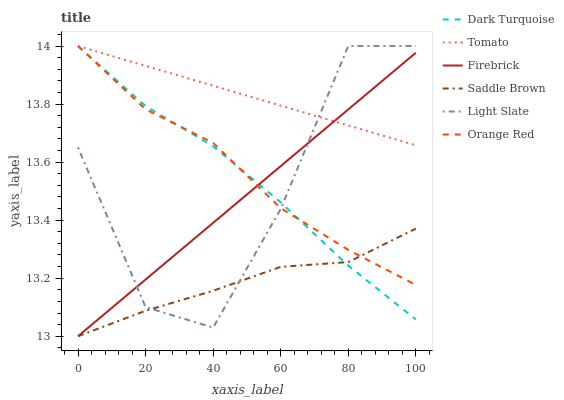Does Saddle Brown have the minimum area under the curve?
Answer yes or no. Yes. Does Tomato have the maximum area under the curve?
Answer yes or no. Yes. Does Light Slate have the minimum area under the curve?
Answer yes or no. No. Does Light Slate have the maximum area under the curve?
Answer yes or no. No. Is Firebrick the smoothest?
Answer yes or no. Yes. Is Light Slate the roughest?
Answer yes or no. Yes. Is Dark Turquoise the smoothest?
Answer yes or no. No. Is Dark Turquoise the roughest?
Answer yes or no. No. Does Firebrick have the lowest value?
Answer yes or no. Yes. Does Light Slate have the lowest value?
Answer yes or no. No. Does Orange Red have the highest value?
Answer yes or no. Yes. Does Firebrick have the highest value?
Answer yes or no. No. Is Saddle Brown less than Tomato?
Answer yes or no. Yes. Is Tomato greater than Saddle Brown?
Answer yes or no. Yes. Does Firebrick intersect Dark Turquoise?
Answer yes or no. Yes. Is Firebrick less than Dark Turquoise?
Answer yes or no. No. Is Firebrick greater than Dark Turquoise?
Answer yes or no. No. Does Saddle Brown intersect Tomato?
Answer yes or no. No. 